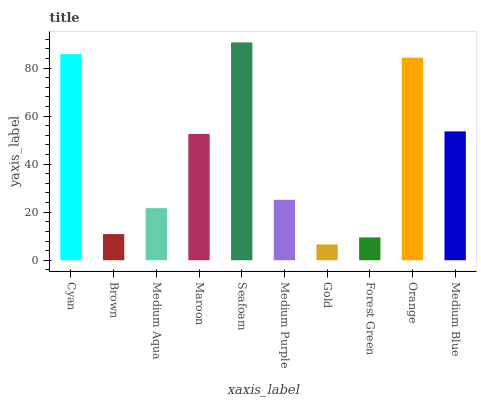Is Gold the minimum?
Answer yes or no. Yes. Is Seafoam the maximum?
Answer yes or no. Yes. Is Brown the minimum?
Answer yes or no. No. Is Brown the maximum?
Answer yes or no. No. Is Cyan greater than Brown?
Answer yes or no. Yes. Is Brown less than Cyan?
Answer yes or no. Yes. Is Brown greater than Cyan?
Answer yes or no. No. Is Cyan less than Brown?
Answer yes or no. No. Is Maroon the high median?
Answer yes or no. Yes. Is Medium Purple the low median?
Answer yes or no. Yes. Is Gold the high median?
Answer yes or no. No. Is Orange the low median?
Answer yes or no. No. 